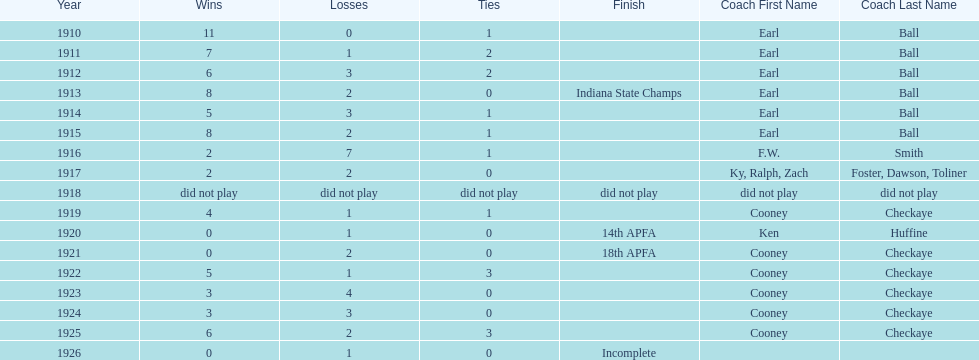Who coached the muncie flyers to an indiana state championship? Earl Ball. 